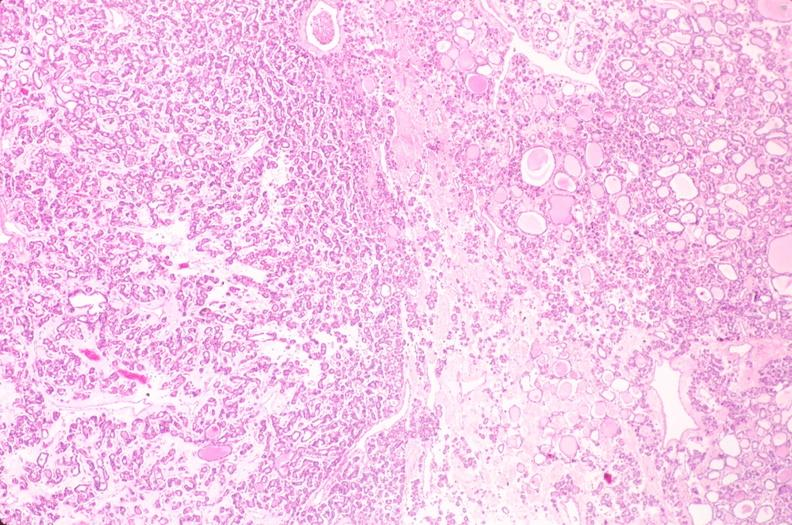s endocrine present?
Answer the question using a single word or phrase. Yes 